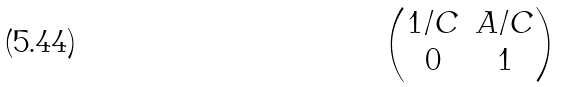<formula> <loc_0><loc_0><loc_500><loc_500>\begin{pmatrix} 1 / C & A / C \\ 0 & 1 \end{pmatrix}</formula> 